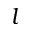Convert formula to latex. <formula><loc_0><loc_0><loc_500><loc_500>l</formula> 